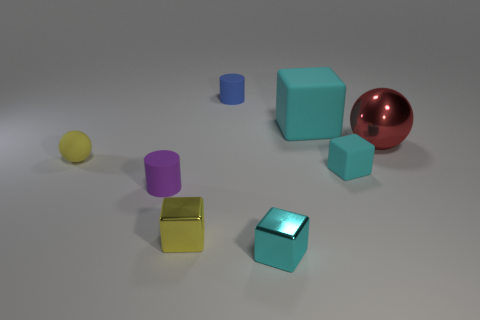There is a rubber thing that is the same color as the tiny rubber cube; what is its shape?
Your answer should be compact. Cube. Are there an equal number of large red metallic things that are behind the large cyan matte cube and blue cylinders?
Provide a short and direct response. No. What number of cylinders are made of the same material as the tiny yellow ball?
Keep it short and to the point. 2. There is a tiny ball that is made of the same material as the small purple object; what is its color?
Keep it short and to the point. Yellow. Does the large red shiny object have the same shape as the purple rubber object?
Keep it short and to the point. No. Is there a big red sphere that is left of the tiny cylinder on the left side of the yellow thing right of the purple rubber cylinder?
Your response must be concise. No. What number of rubber cylinders are the same color as the small matte sphere?
Keep it short and to the point. 0. There is a cyan object that is the same size as the red metallic object; what shape is it?
Offer a terse response. Cube. There is a tiny rubber cube; are there any tiny yellow matte balls in front of it?
Make the answer very short. No. Do the yellow metallic object and the red metal ball have the same size?
Provide a short and direct response. No. 